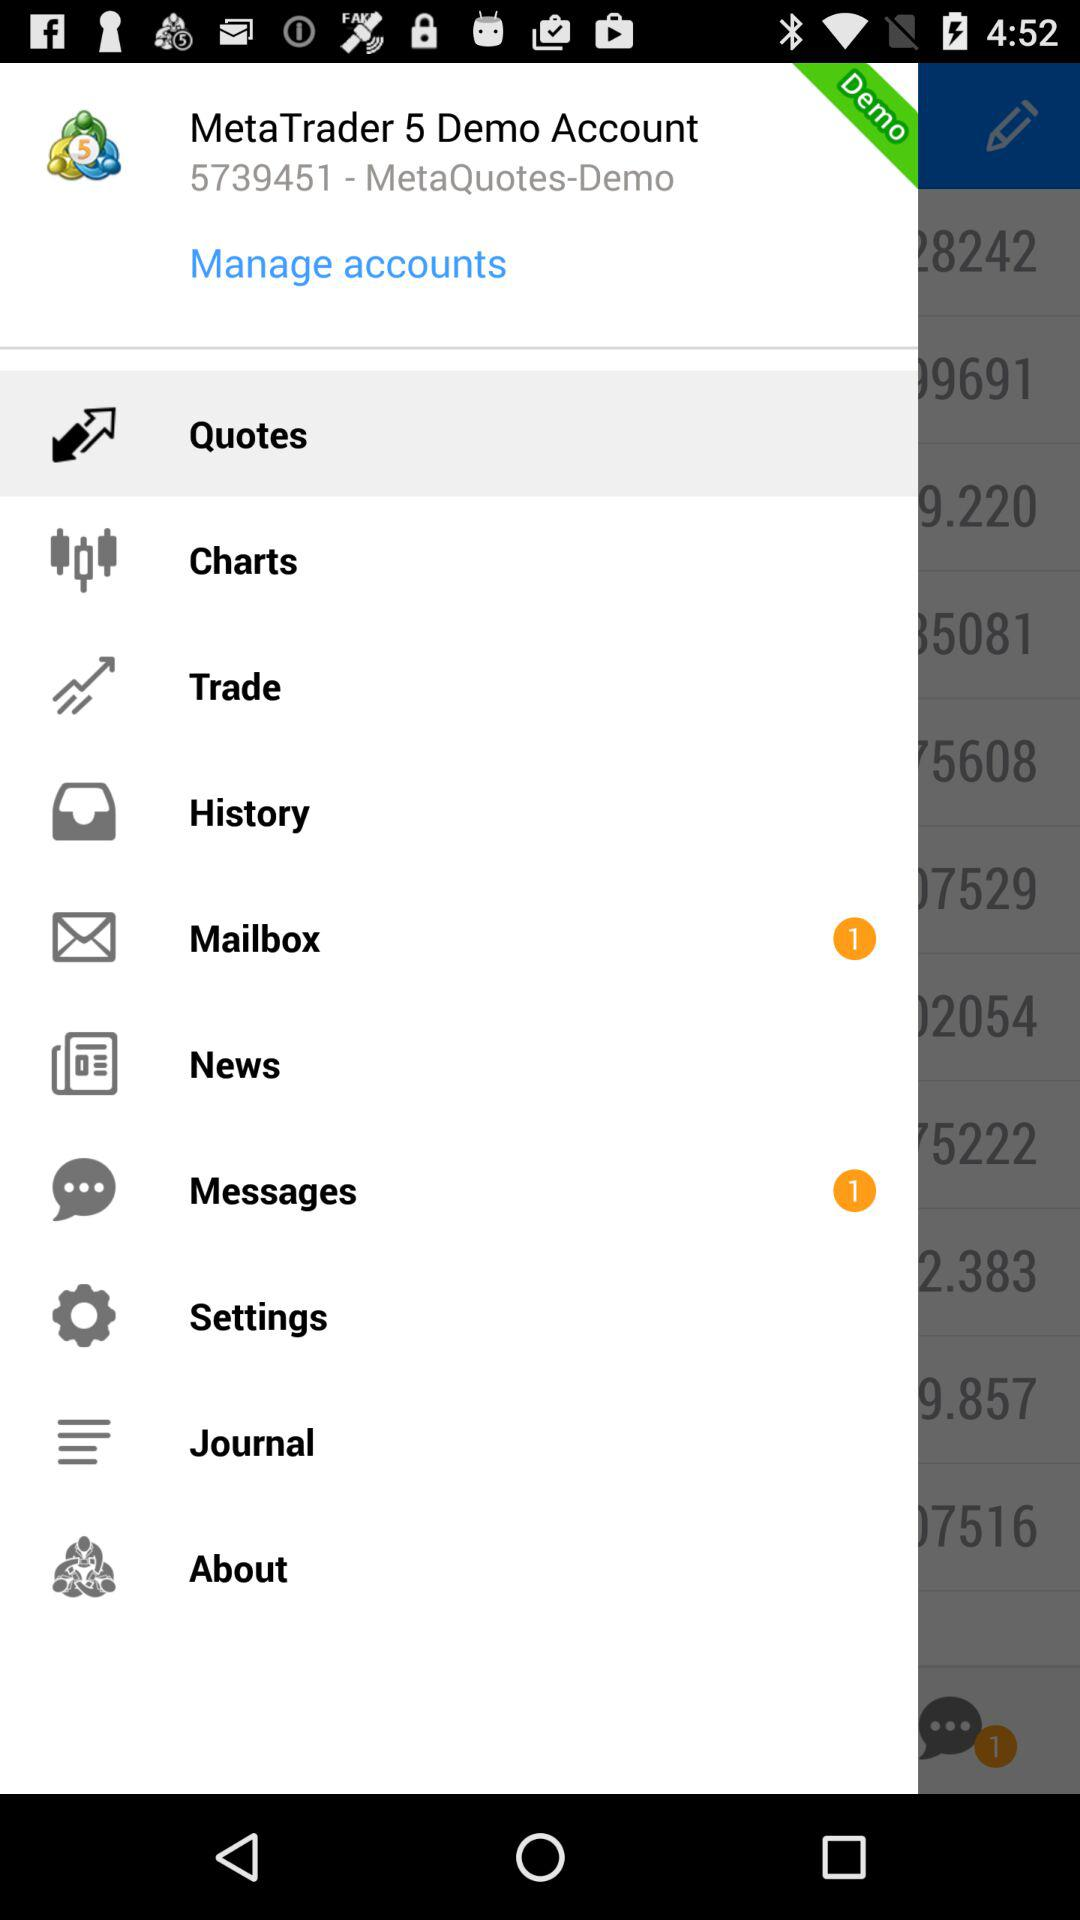How many unread messages are there in the mailbox? There is 1 unread message. 